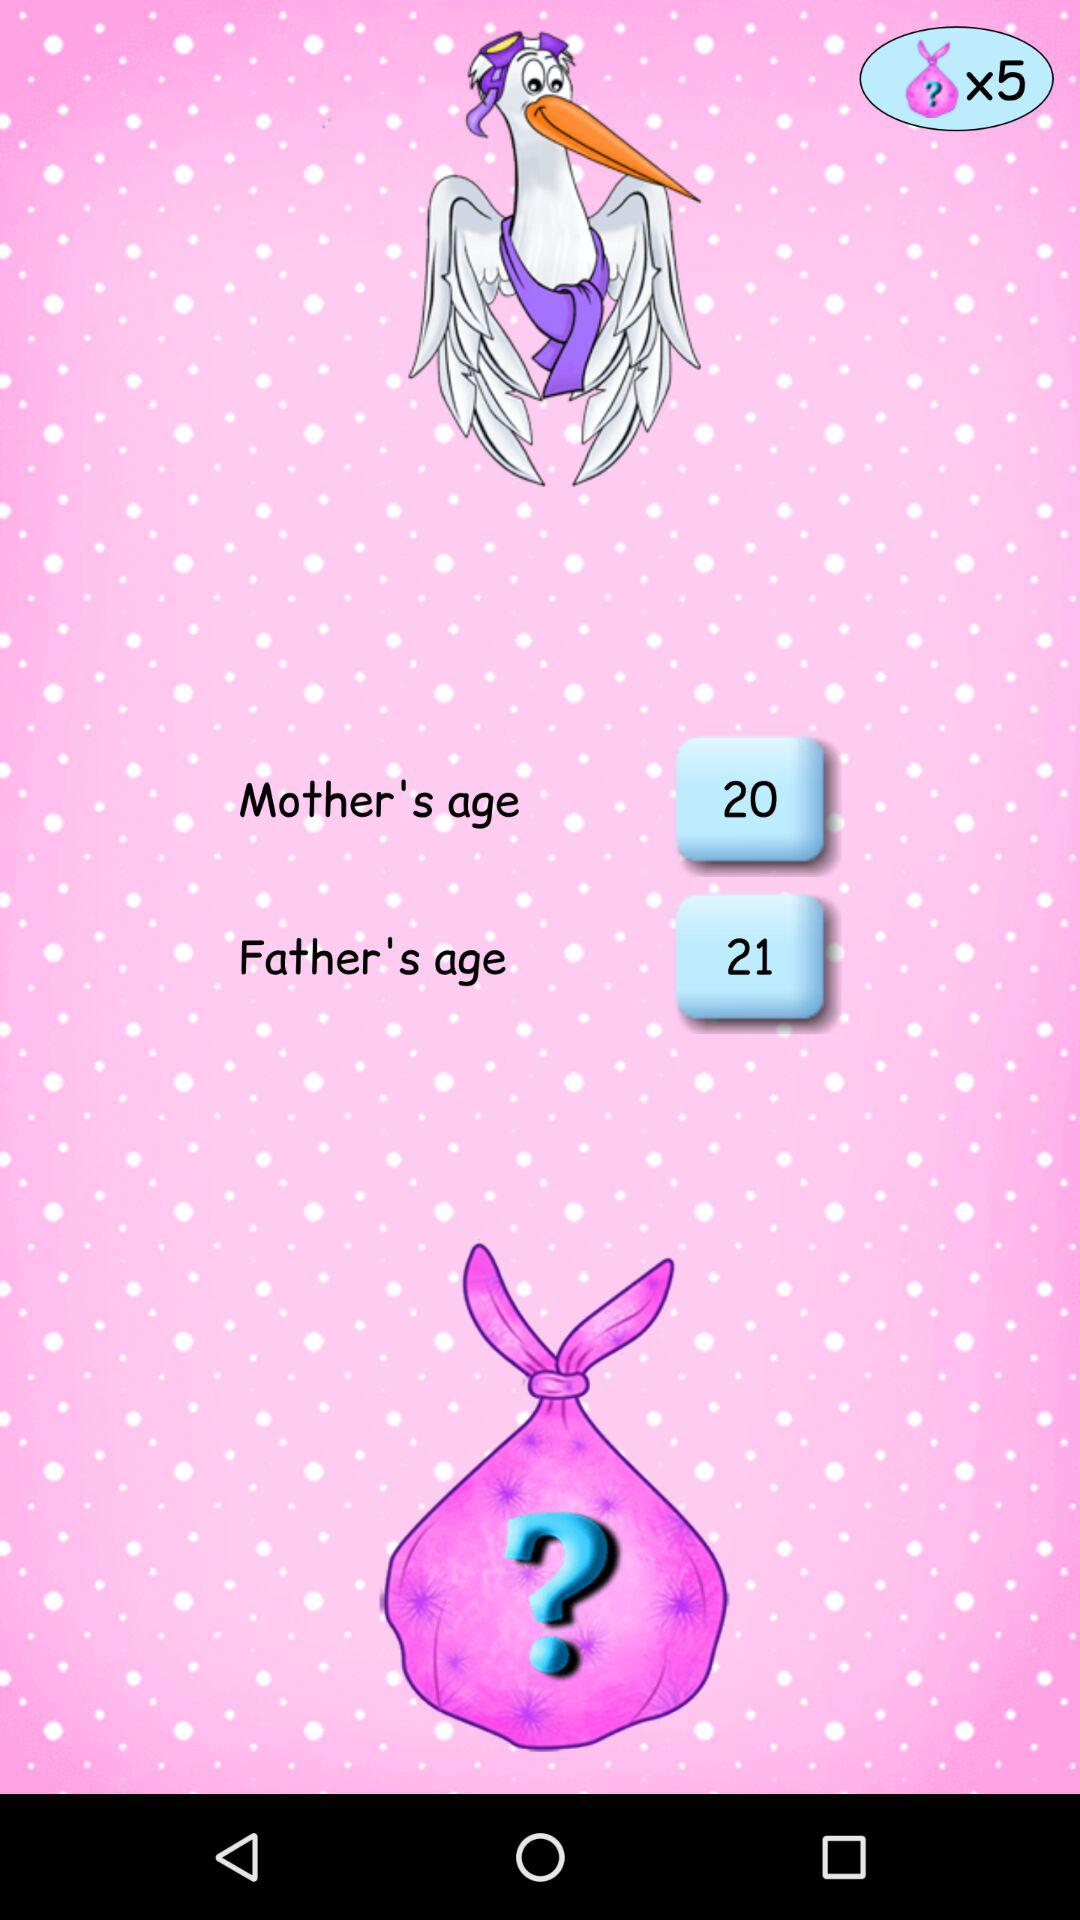What is the father's age? The father is 21 years old. 